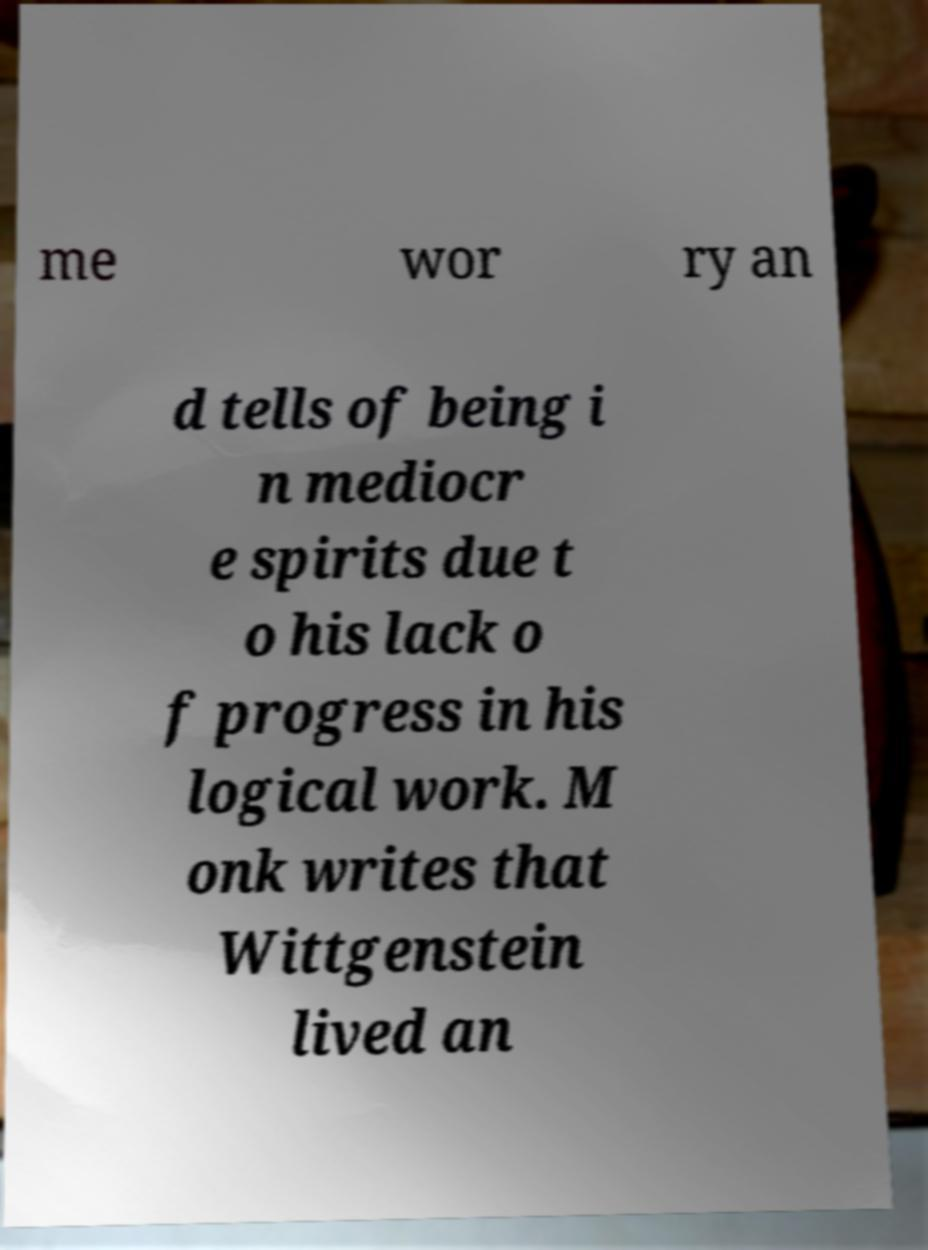There's text embedded in this image that I need extracted. Can you transcribe it verbatim? me wor ry an d tells of being i n mediocr e spirits due t o his lack o f progress in his logical work. M onk writes that Wittgenstein lived an 